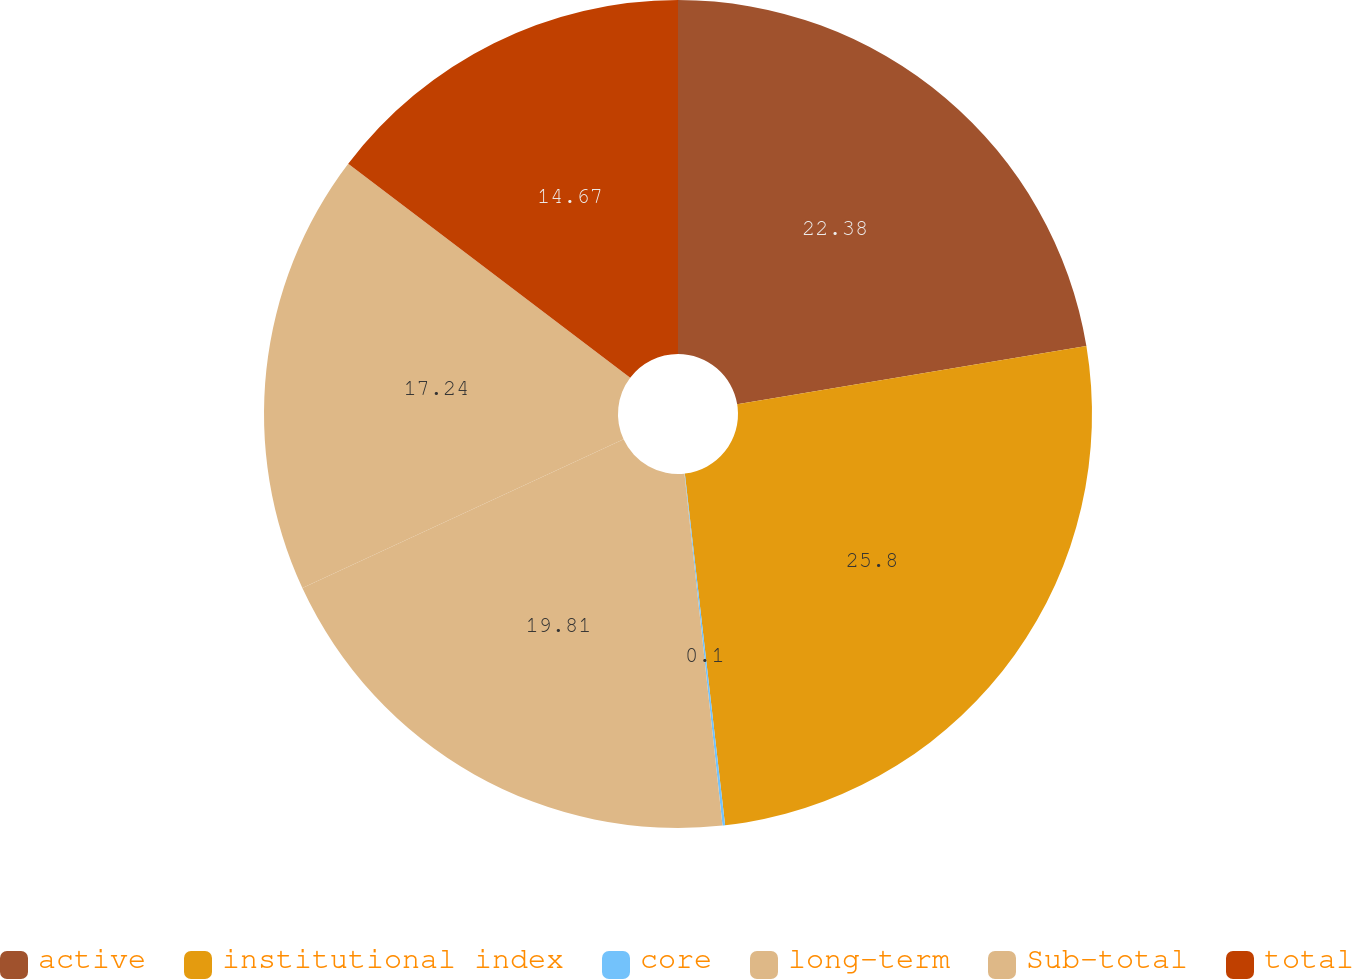<chart> <loc_0><loc_0><loc_500><loc_500><pie_chart><fcel>active<fcel>institutional index<fcel>core<fcel>long-term<fcel>Sub-total<fcel>total<nl><fcel>22.38%<fcel>25.81%<fcel>0.1%<fcel>19.81%<fcel>17.24%<fcel>14.67%<nl></chart> 